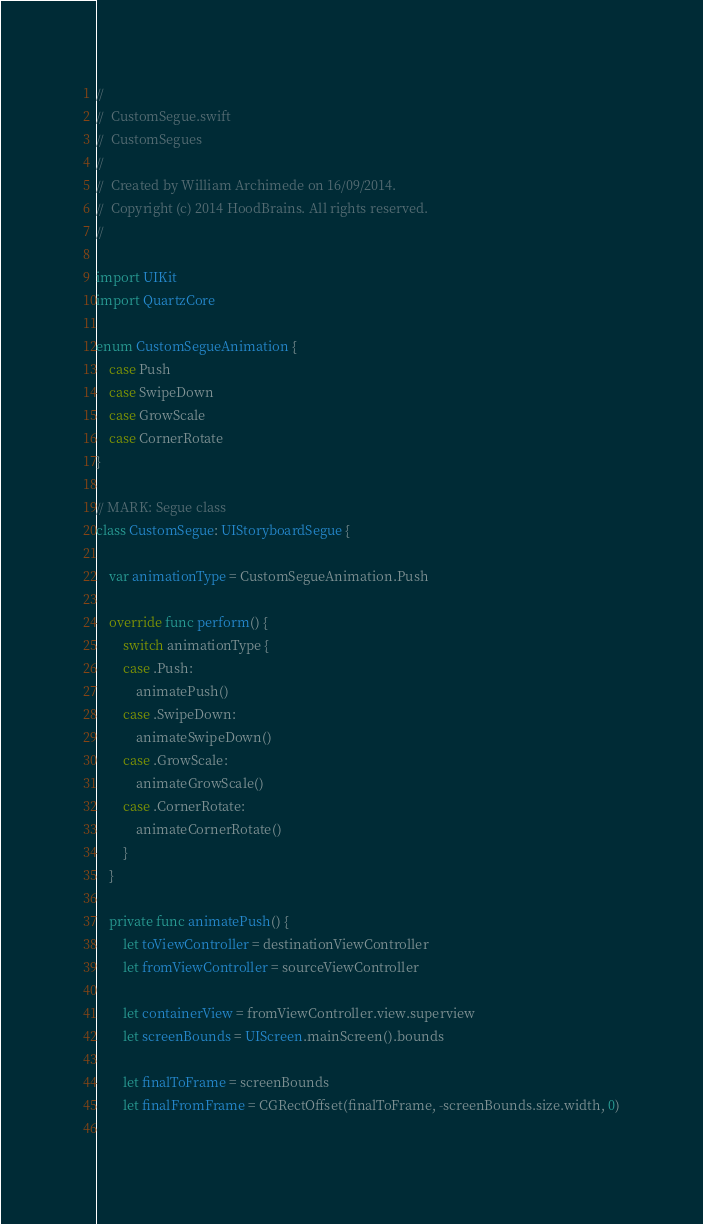<code> <loc_0><loc_0><loc_500><loc_500><_Swift_>//
//  CustomSegue.swift
//  CustomSegues
//
//  Created by William Archimede on 16/09/2014.
//  Copyright (c) 2014 HoodBrains. All rights reserved.
//

import UIKit
import QuartzCore

enum CustomSegueAnimation {
    case Push
    case SwipeDown
    case GrowScale
    case CornerRotate
}

// MARK: Segue class
class CustomSegue: UIStoryboardSegue {
    
    var animationType = CustomSegueAnimation.Push
    
    override func perform() {
        switch animationType {
        case .Push:
            animatePush()
        case .SwipeDown:
            animateSwipeDown()
        case .GrowScale:
            animateGrowScale()
        case .CornerRotate:
            animateCornerRotate()
        }
    }
    
    private func animatePush() {
        let toViewController = destinationViewController
        let fromViewController = sourceViewController
        
        let containerView = fromViewController.view.superview
        let screenBounds = UIScreen.mainScreen().bounds
        
        let finalToFrame = screenBounds
        let finalFromFrame = CGRectOffset(finalToFrame, -screenBounds.size.width, 0)
        </code> 